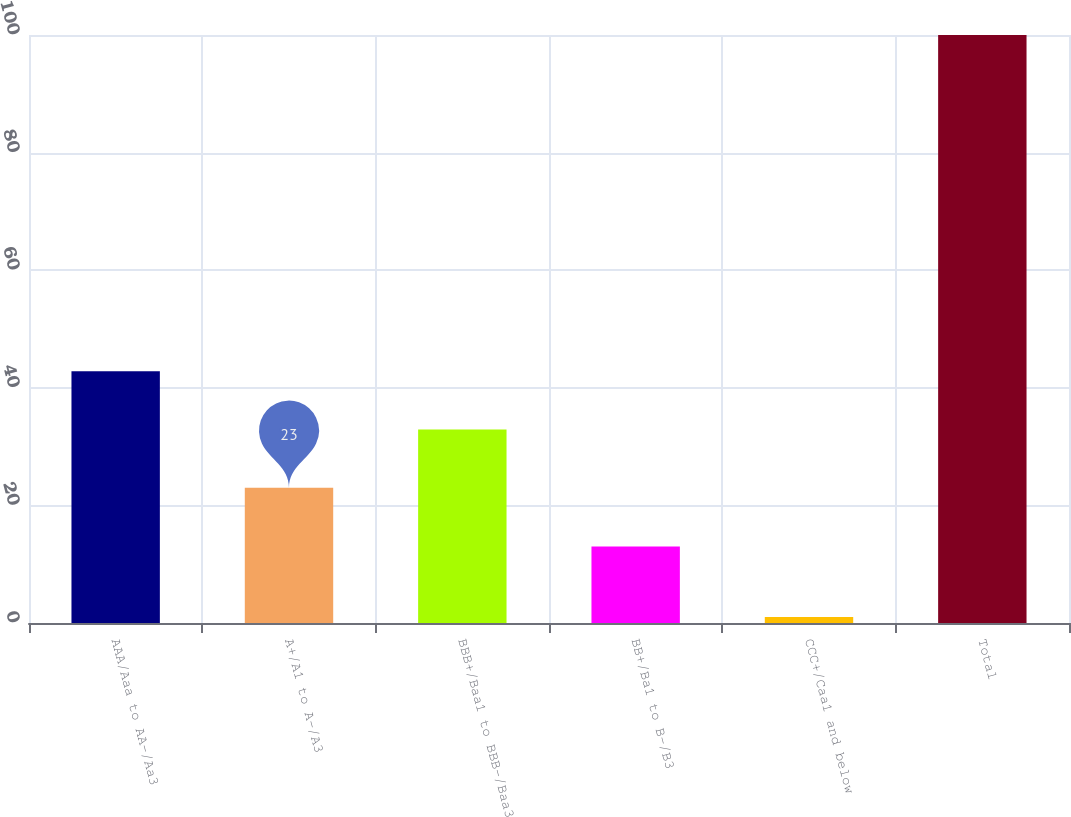Convert chart to OTSL. <chart><loc_0><loc_0><loc_500><loc_500><bar_chart><fcel>AAA/Aaa to AA-/Aa3<fcel>A+/A1 to A-/A3<fcel>BBB+/Baa1 to BBB-/Baa3<fcel>BB+/Ba1 to B-/B3<fcel>CCC+/Caa1 and below<fcel>Total<nl><fcel>42.8<fcel>23<fcel>32.9<fcel>13<fcel>1<fcel>100<nl></chart> 